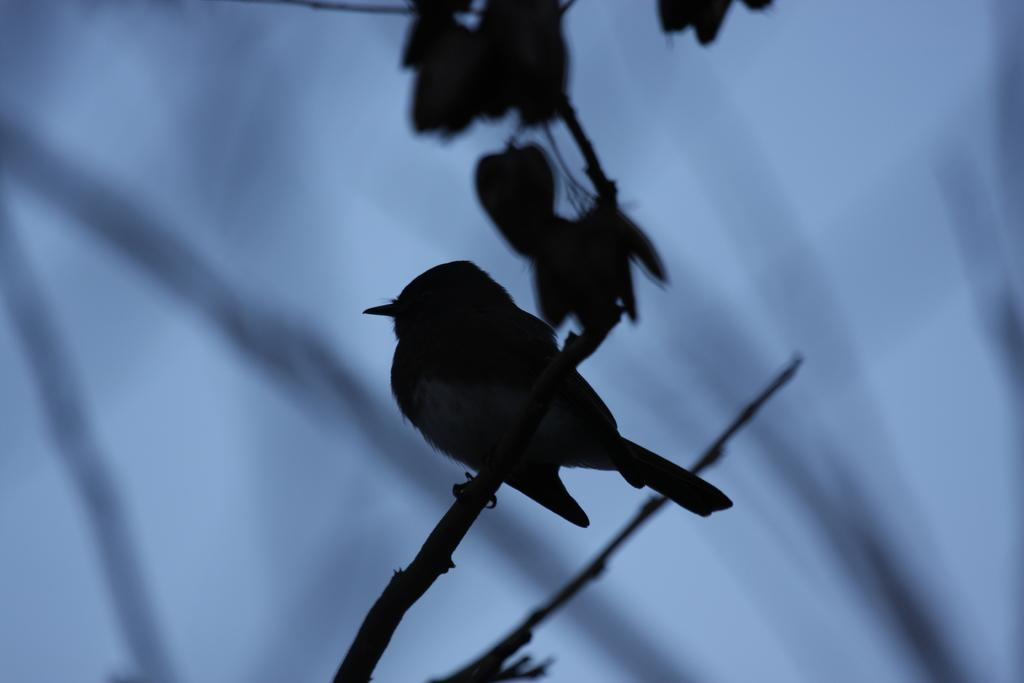What type of animal is in the image? There is a bird in the image. Where is the bird located in the image? The bird is standing on a branch. What else can be seen in the image besides the bird? There are leaves visible in the image. How would you describe the background of the image? The background of the image is blurry and blue. What type of rifle is the bird holding in the image? There is no rifle present in the image; the bird is standing on a branch. How many yards of fabric are used to create the art in the image? There is no art or fabric present in the image; it features a bird standing on a branch with leaves in the background. 